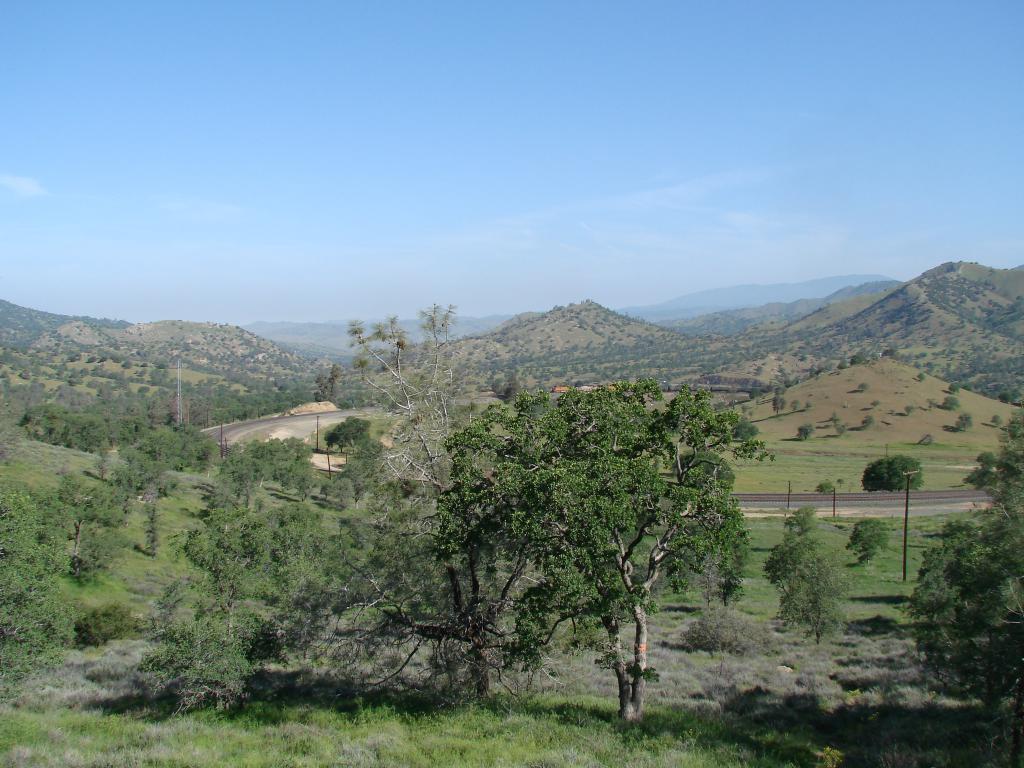In one or two sentences, can you explain what this image depicts? In this image we can see trees, grass, plants, hills, road, poles and in the background there is a sky. 